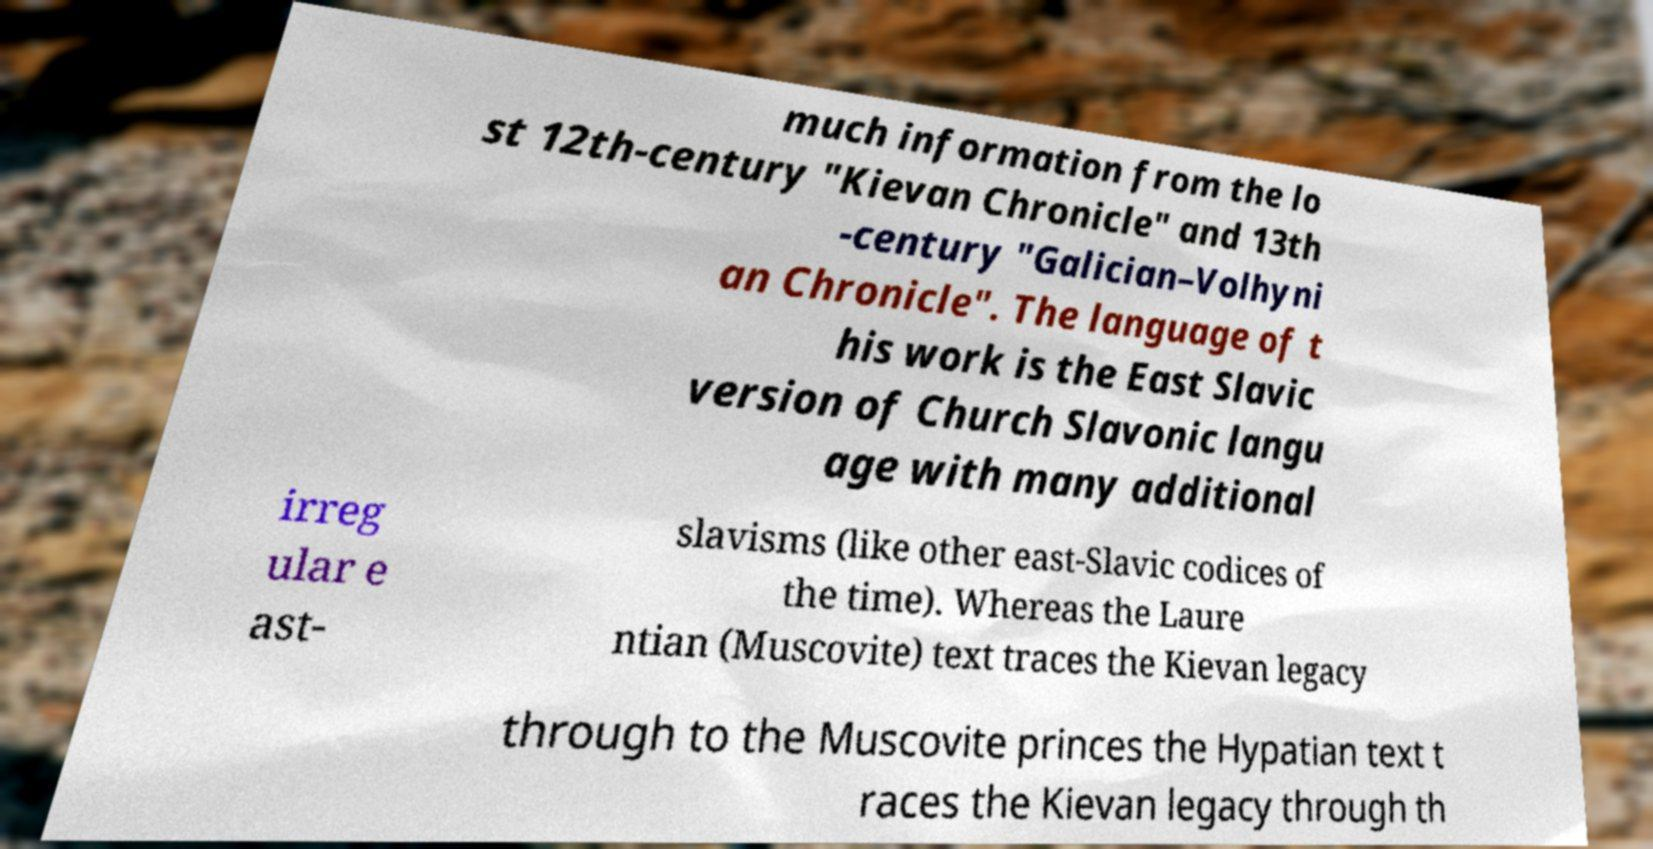Could you assist in decoding the text presented in this image and type it out clearly? much information from the lo st 12th-century "Kievan Chronicle" and 13th -century "Galician–Volhyni an Chronicle". The language of t his work is the East Slavic version of Church Slavonic langu age with many additional irreg ular e ast- slavisms (like other east-Slavic codices of the time). Whereas the Laure ntian (Muscovite) text traces the Kievan legacy through to the Muscovite princes the Hypatian text t races the Kievan legacy through th 